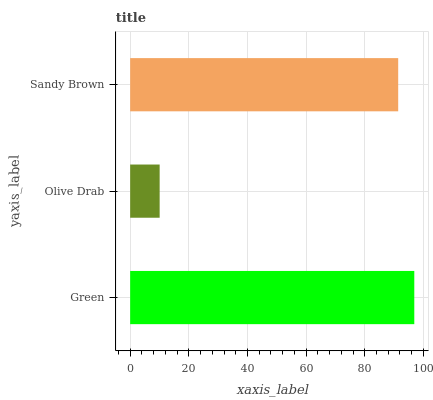Is Olive Drab the minimum?
Answer yes or no. Yes. Is Green the maximum?
Answer yes or no. Yes. Is Sandy Brown the minimum?
Answer yes or no. No. Is Sandy Brown the maximum?
Answer yes or no. No. Is Sandy Brown greater than Olive Drab?
Answer yes or no. Yes. Is Olive Drab less than Sandy Brown?
Answer yes or no. Yes. Is Olive Drab greater than Sandy Brown?
Answer yes or no. No. Is Sandy Brown less than Olive Drab?
Answer yes or no. No. Is Sandy Brown the high median?
Answer yes or no. Yes. Is Sandy Brown the low median?
Answer yes or no. Yes. Is Green the high median?
Answer yes or no. No. Is Green the low median?
Answer yes or no. No. 